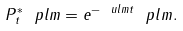Convert formula to latex. <formula><loc_0><loc_0><loc_500><loc_500>P ^ { * } _ { t } \ p l m = e ^ { - \ u l m t } \ p l m .</formula> 